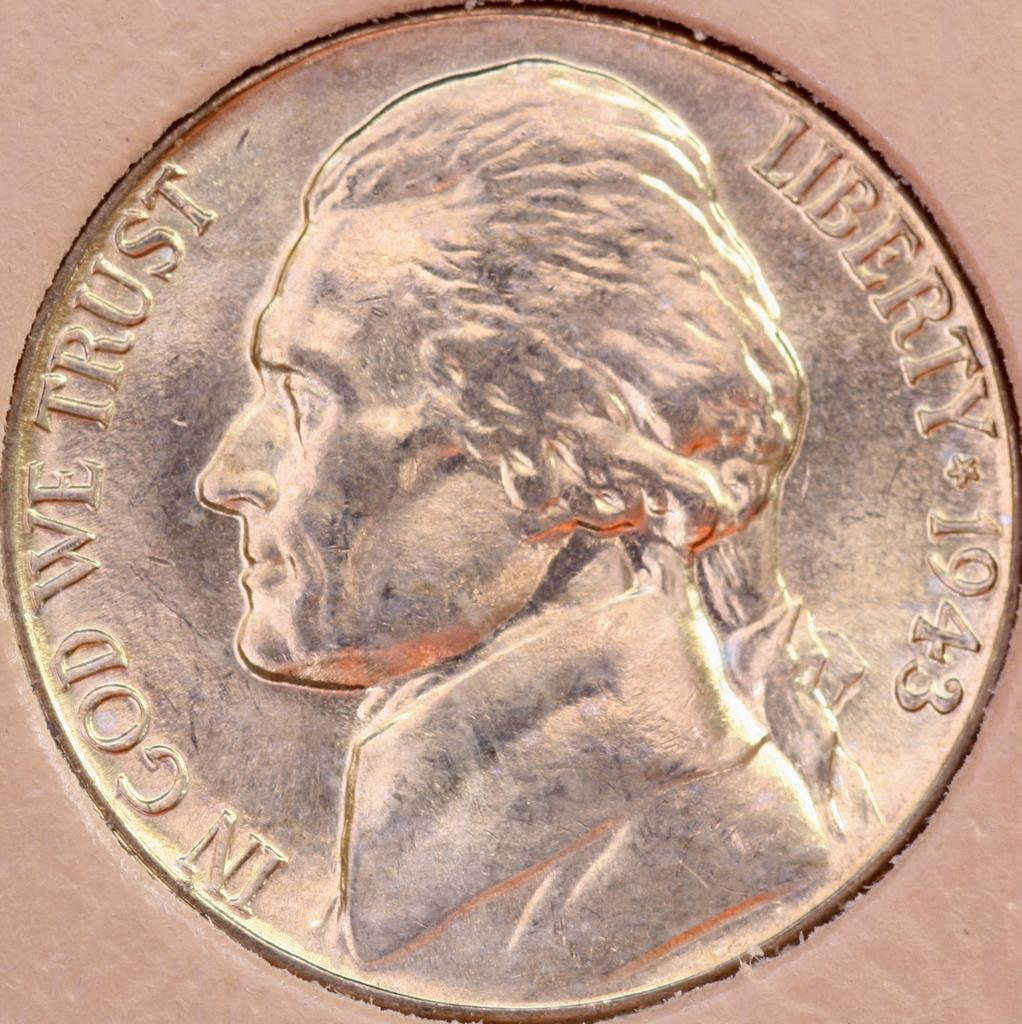<image>
Give a short and clear explanation of the subsequent image. A nickel is shown close up with the words In God We Trust, Liberty 1943 around the edge. 